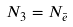Convert formula to latex. <formula><loc_0><loc_0><loc_500><loc_500>N _ { 3 } = N _ { \bar { e } }</formula> 